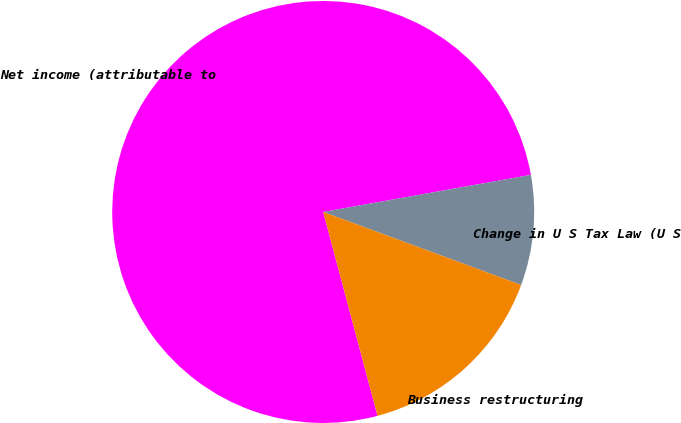Convert chart. <chart><loc_0><loc_0><loc_500><loc_500><pie_chart><fcel>Net income (attributable to<fcel>Change in U S Tax Law (U S<fcel>Business restructuring<nl><fcel>76.34%<fcel>8.44%<fcel>15.23%<nl></chart> 